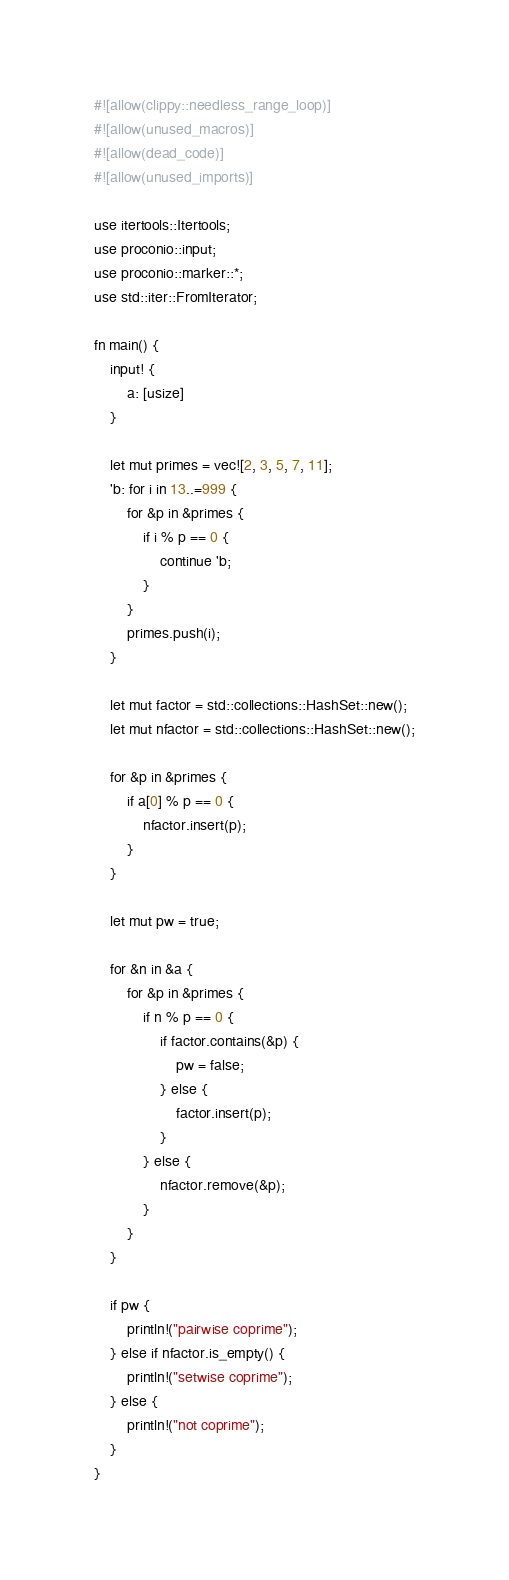<code> <loc_0><loc_0><loc_500><loc_500><_Rust_>#![allow(clippy::needless_range_loop)]
#![allow(unused_macros)]
#![allow(dead_code)]
#![allow(unused_imports)]

use itertools::Itertools;
use proconio::input;
use proconio::marker::*;
use std::iter::FromIterator;

fn main() {
    input! {
        a: [usize]
    }

    let mut primes = vec![2, 3, 5, 7, 11];
    'b: for i in 13..=999 {
        for &p in &primes {
            if i % p == 0 {
                continue 'b;
            }
        }
        primes.push(i);
    }

    let mut factor = std::collections::HashSet::new();
    let mut nfactor = std::collections::HashSet::new();

    for &p in &primes {
        if a[0] % p == 0 {
            nfactor.insert(p);
        }
    }

    let mut pw = true;

    for &n in &a {
        for &p in &primes {
            if n % p == 0 {
                if factor.contains(&p) {
                    pw = false;
                } else {
                    factor.insert(p);
                }
            } else {
                nfactor.remove(&p);
            }
        }
    }

    if pw {
        println!("pairwise coprime");
    } else if nfactor.is_empty() {
        println!("setwise coprime");
    } else {
        println!("not coprime");
    }
}
</code> 